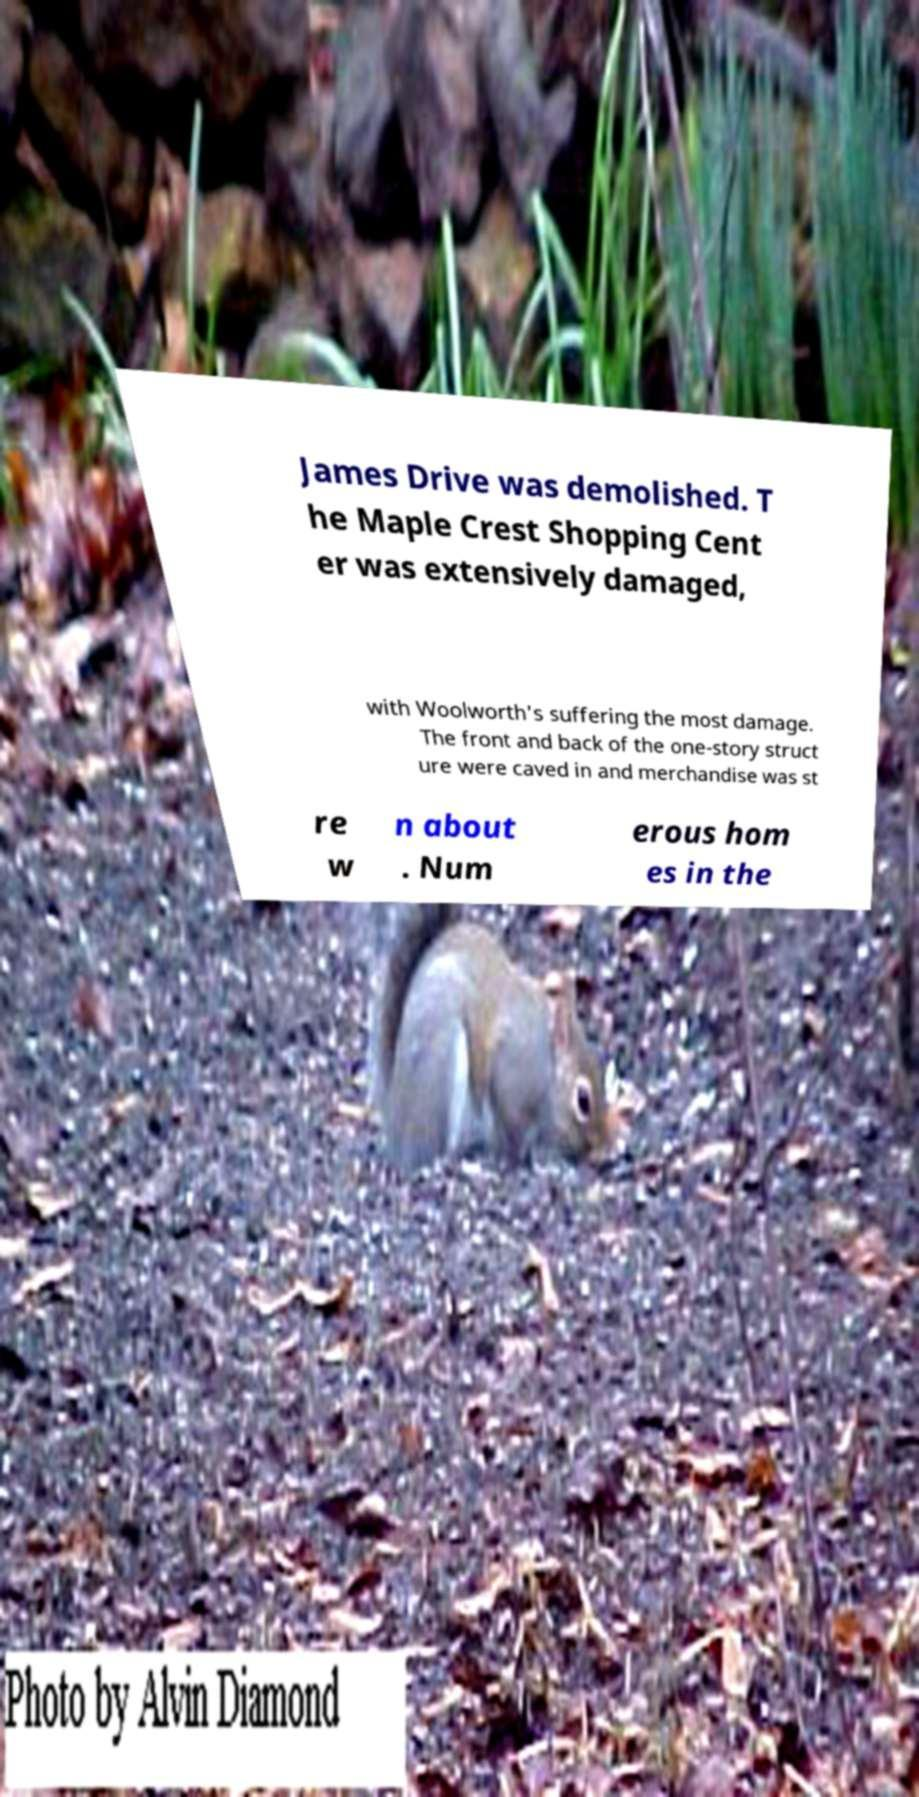Please identify and transcribe the text found in this image. James Drive was demolished. T he Maple Crest Shopping Cent er was extensively damaged, with Woolworth's suffering the most damage. The front and back of the one-story struct ure were caved in and merchandise was st re w n about . Num erous hom es in the 